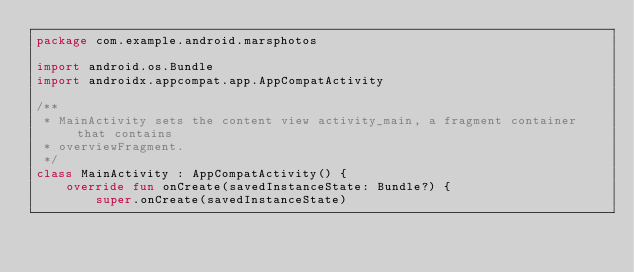<code> <loc_0><loc_0><loc_500><loc_500><_Kotlin_>package com.example.android.marsphotos

import android.os.Bundle
import androidx.appcompat.app.AppCompatActivity

/**
 * MainActivity sets the content view activity_main, a fragment container that contains
 * overviewFragment.
 */
class MainActivity : AppCompatActivity() {
    override fun onCreate(savedInstanceState: Bundle?) {
        super.onCreate(savedInstanceState)</code> 